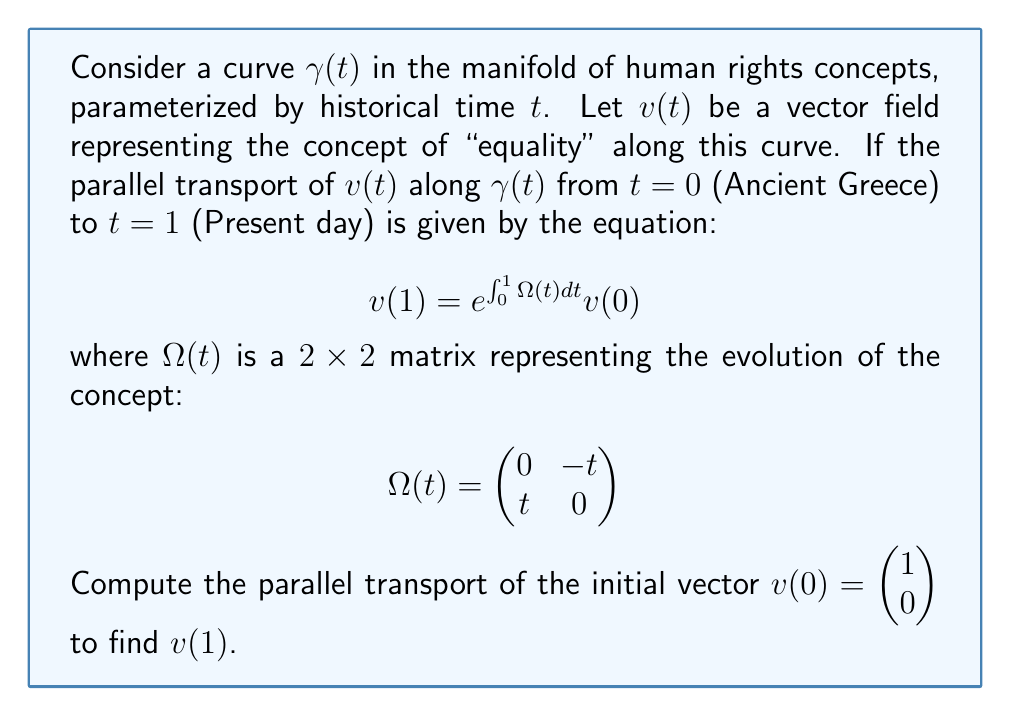What is the answer to this math problem? To solve this problem, we need to follow these steps:

1) First, we need to calculate $\int_0^1 \Omega(t) dt$:

   $$\int_0^1 \Omega(t) dt = \int_0^1 \begin{pmatrix} 0 & -t \\ t & 0 \end{pmatrix} dt = \begin{pmatrix} 0 & -\frac{1}{2} \\ \frac{1}{2} & 0 \end{pmatrix}$$

2) Now, we need to compute $e^{\int_0^1 \Omega(t) dt}$. For a $2\times2$ matrix $A = \begin{pmatrix} 0 & -a \\ a & 0 \end{pmatrix}$, the matrix exponential is given by:

   $$e^A = \begin{pmatrix} \cos a & -\sin a \\ \sin a & \cos a \end{pmatrix}$$

   In our case, $a = \frac{1}{2}$, so:

   $$e^{\int_0^1 \Omega(t) dt} = \begin{pmatrix} \cos \frac{1}{2} & -\sin \frac{1}{2} \\ \sin \frac{1}{2} & \cos \frac{1}{2} \end{pmatrix}$$

3) Finally, we multiply this matrix by $v(0)$:

   $$v(1) = \begin{pmatrix} \cos \frac{1}{2} & -\sin \frac{1}{2} \\ \sin \frac{1}{2} & \cos \frac{1}{2} \end{pmatrix} \begin{pmatrix} 1 \\ 0 \end{pmatrix} = \begin{pmatrix} \cos \frac{1}{2} \\ \sin \frac{1}{2} \end{pmatrix}$$

This result shows how the concept of "equality" has evolved from Ancient Greece to the present day, with its components changing according to the parallel transport along the historical timeline.
Answer: $v(1) = \begin{pmatrix} \cos \frac{1}{2} \\ \sin \frac{1}{2} \end{pmatrix}$ 